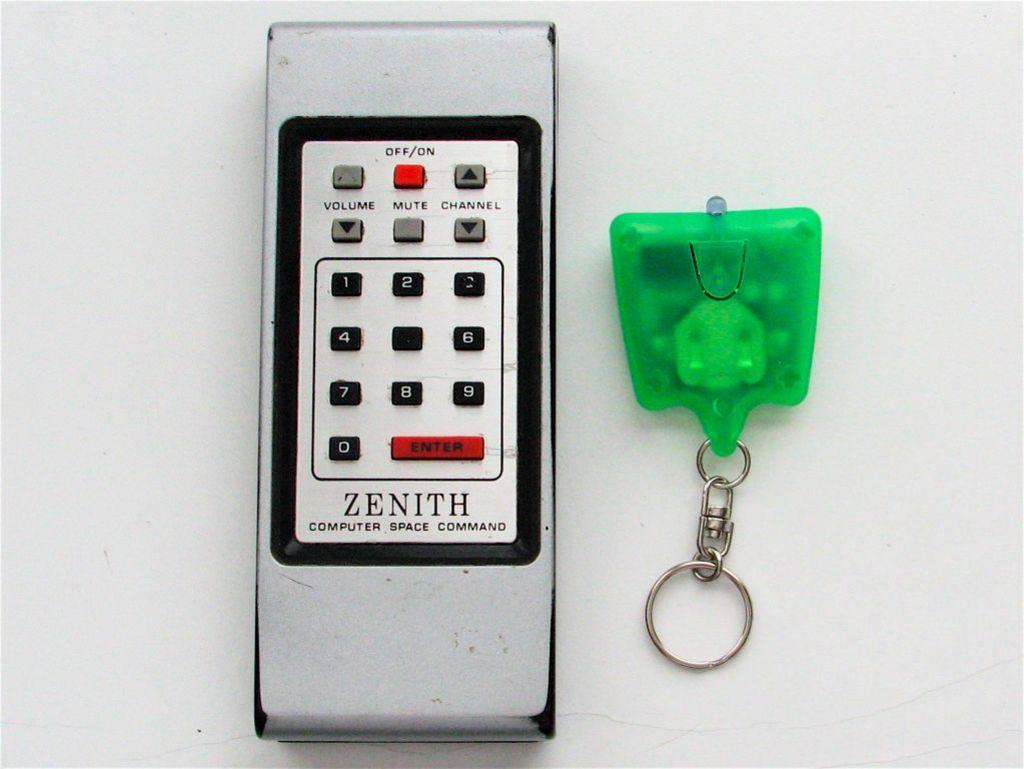<image>
Give a short and clear explanation of the subsequent image. A Zenith television remote sits next to a green keychain. 